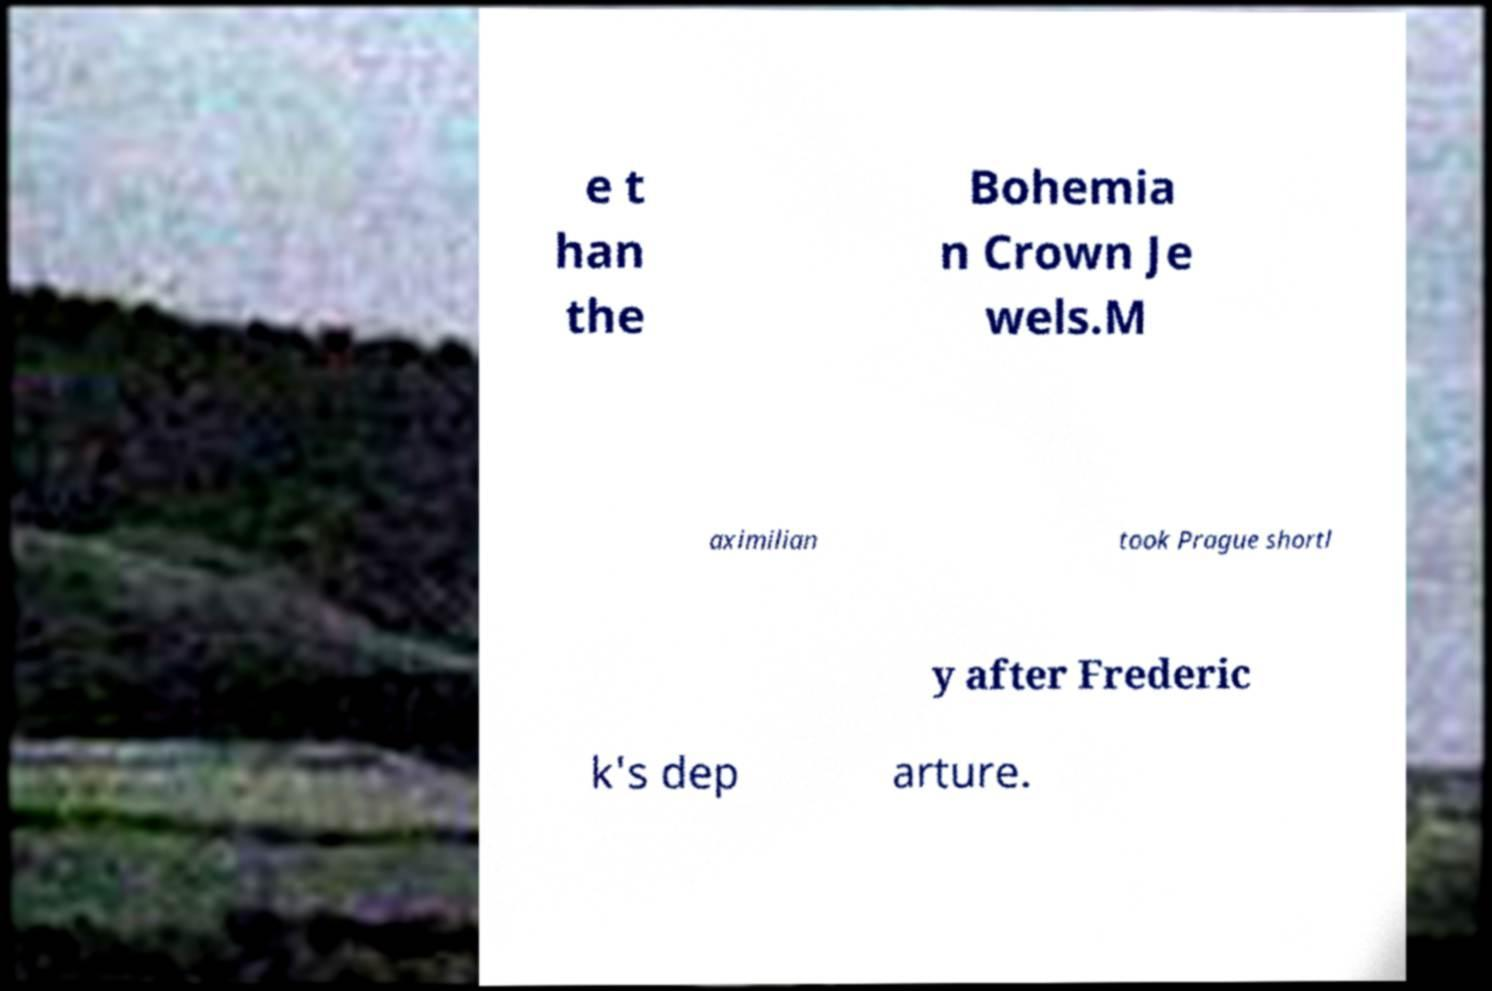Can you accurately transcribe the text from the provided image for me? e t han the Bohemia n Crown Je wels.M aximilian took Prague shortl y after Frederic k's dep arture. 